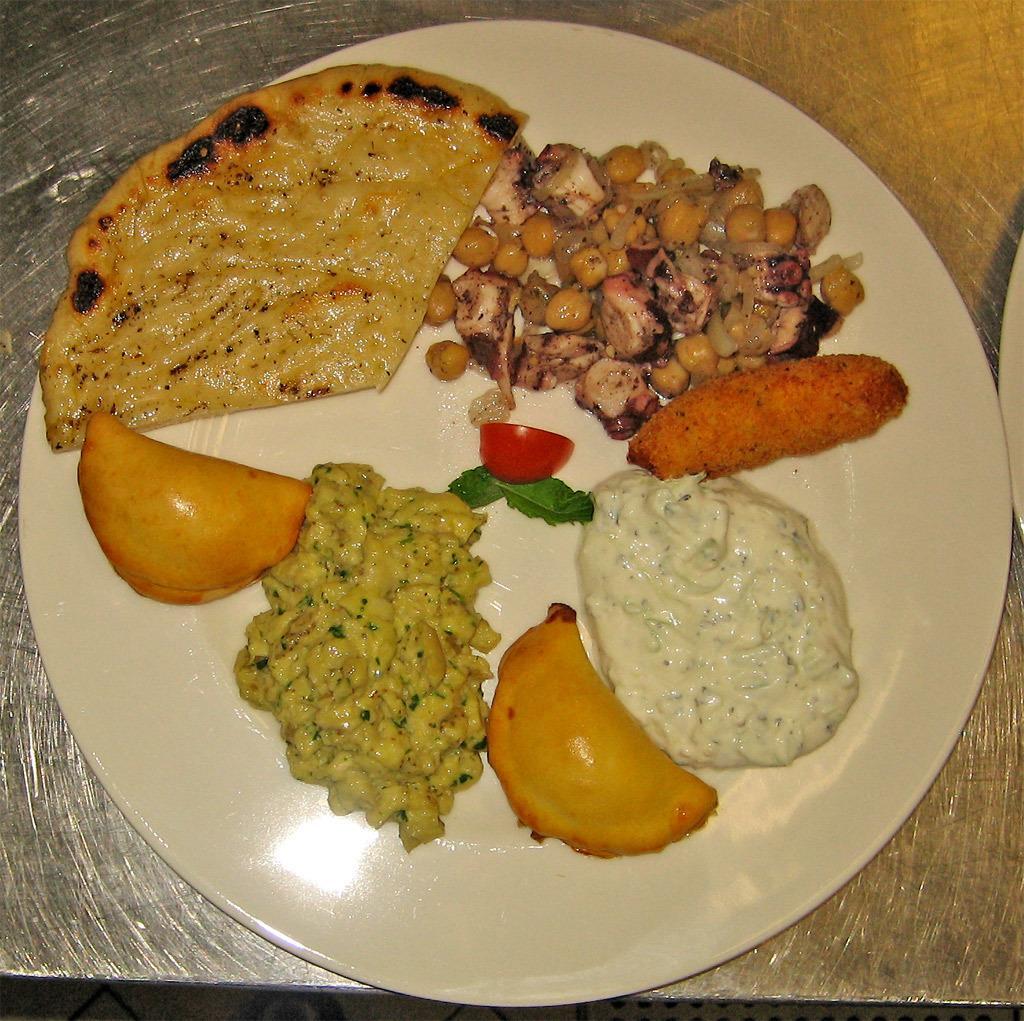Can you describe this image briefly? In this image, I can see the food items on a plate, which is kept on an object. 